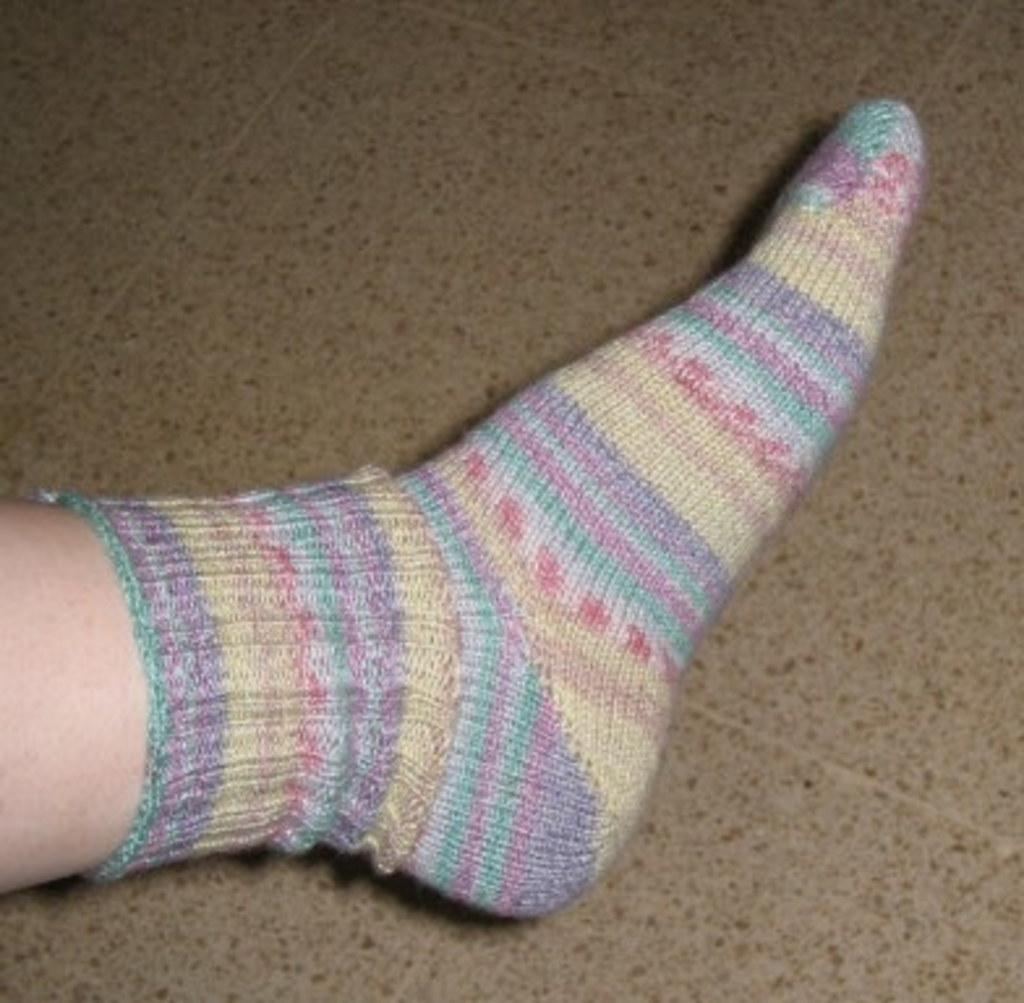Describe this image in one or two sentences. In this image I can see a person's leg and I can see he is wearing a socks which is yellow, red, green, blue and purple in color. I can see the brown colored surface in the background. 